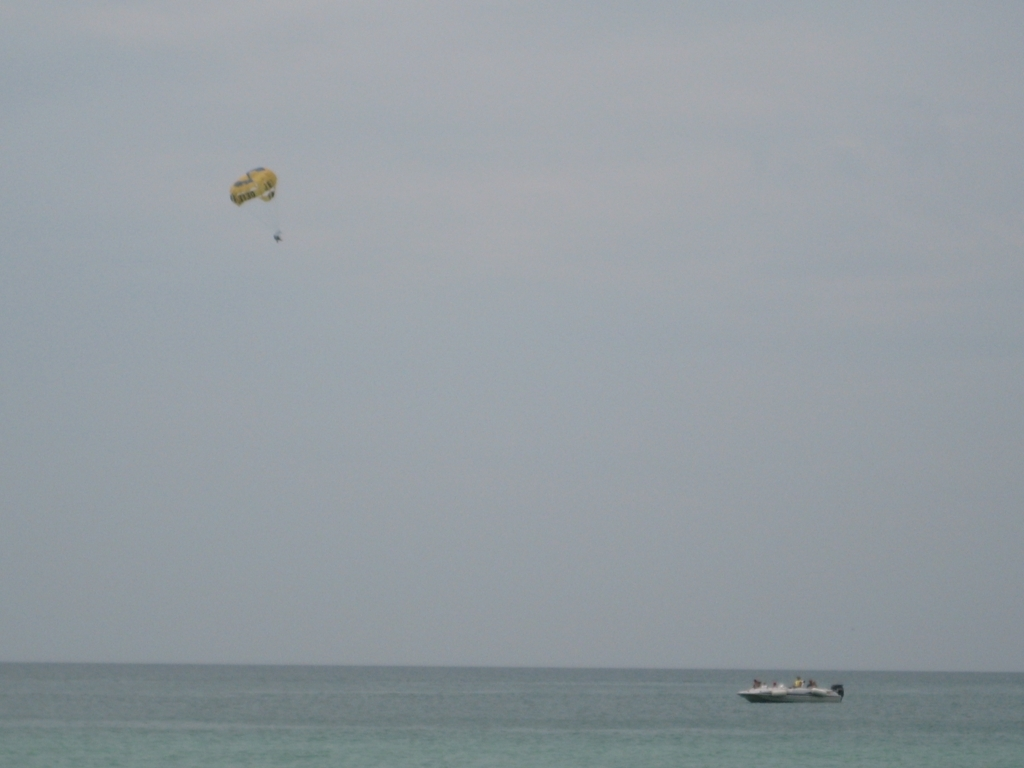What is the overall quality of the image?
A. Exceptional
B. Above average
C. Below average
Answer with the option's letter from the given choices directly. The overall quality of the image can be considered as 'C' which stands for Below Average. The reasons for this assessment include a lack of sharpness and detail, a fairly plain composition with considerable negative space, and a generally muted color palette. Although the subject matter might hold some interest, depicting parasailing and a boat at sea, the execution does not elevate the image to a higher quality bracket. 